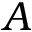Convert formula to latex. <formula><loc_0><loc_0><loc_500><loc_500>A</formula> 